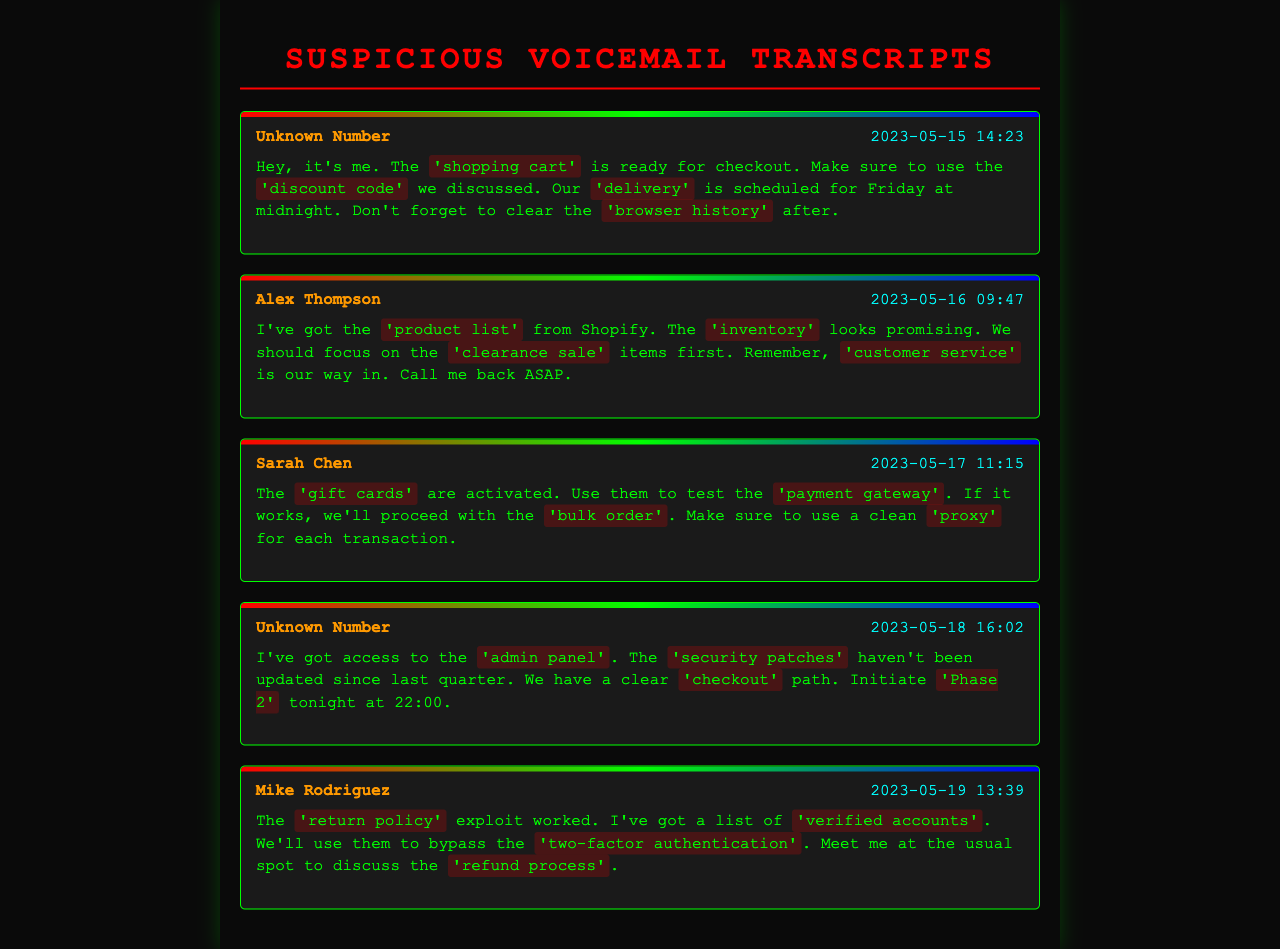what was the date and time of the first voicemail? The first voicemail was recorded on May 15, 2023, at 14:23.
Answer: 2023-05-15 14:23 who left the voicemail on May 16, 2023? The voicemail on May 16, 2023, was left by Alex Thompson.
Answer: Alex Thompson what phrase indicates a potential breach regarding security in the third voicemail? The phrase “security patches” suggests a focus on vulnerabilities that could be exploited.
Answer: security patches what action is mentioned in the voicemail from May 18, 2023? The action proposed is to initiate "Phase 2" at 22:00.
Answer: initiate Phase 2 which caller discussed using gift cards? Sarah Chen is the caller who mentioned using gift cards.
Answer: Sarah Chen how many voicemails indicate a planned breach? There are four voicemails that display indications of a planned breach.
Answer: four what was highlighted as a method to bypass security? The method to bypass security mentioned was “verified accounts.”
Answer: verified accounts what is the scheduled delivery time mentioned in the first voicemail? The scheduled delivery time is at midnight on Friday.
Answer: Friday at midnight what kind of testing is implied in Sarah Chen's voicemail? Testing of the "payment gateway" is implied in her voicemail.
Answer: payment gateway 